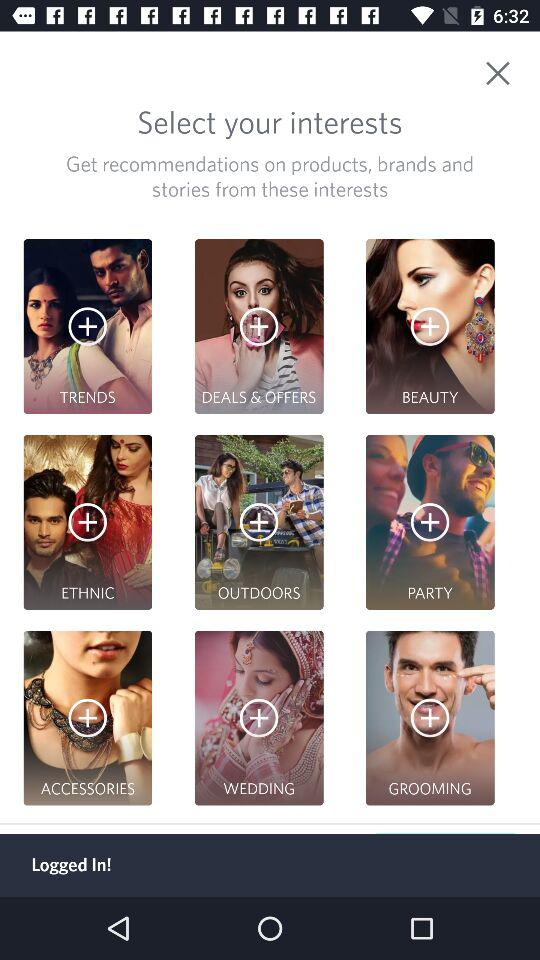What are the different categories of interest shown? The different categories are "TRENDS", "DEALS & OFFERS", "BEAUTY", "ETHNIC", "OUTDOORS", "PARTY", "ACCESSORIES", "WEDDING" and "GROOMING". 